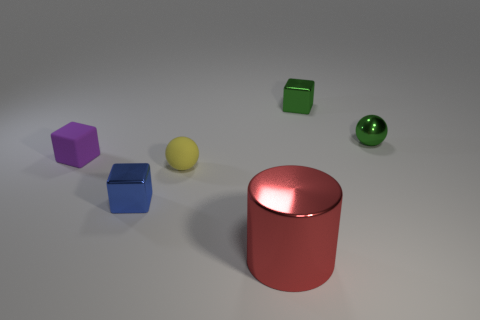Subtract all green cubes. How many cubes are left? 2 Add 4 blocks. How many objects exist? 10 Subtract all blue cubes. How many cubes are left? 2 Subtract all cylinders. How many objects are left? 5 Subtract 0 cyan balls. How many objects are left? 6 Subtract 2 cubes. How many cubes are left? 1 Subtract all purple balls. Subtract all green cylinders. How many balls are left? 2 Subtract all tiny green shiny balls. Subtract all shiny cylinders. How many objects are left? 4 Add 6 tiny balls. How many tiny balls are left? 8 Add 2 small blue cubes. How many small blue cubes exist? 3 